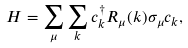Convert formula to latex. <formula><loc_0><loc_0><loc_500><loc_500>H = \sum _ { \mu } \sum _ { k } c _ { k } ^ { \dagger } R _ { \mu } ( k ) \sigma _ { \mu } c _ { k } ,</formula> 